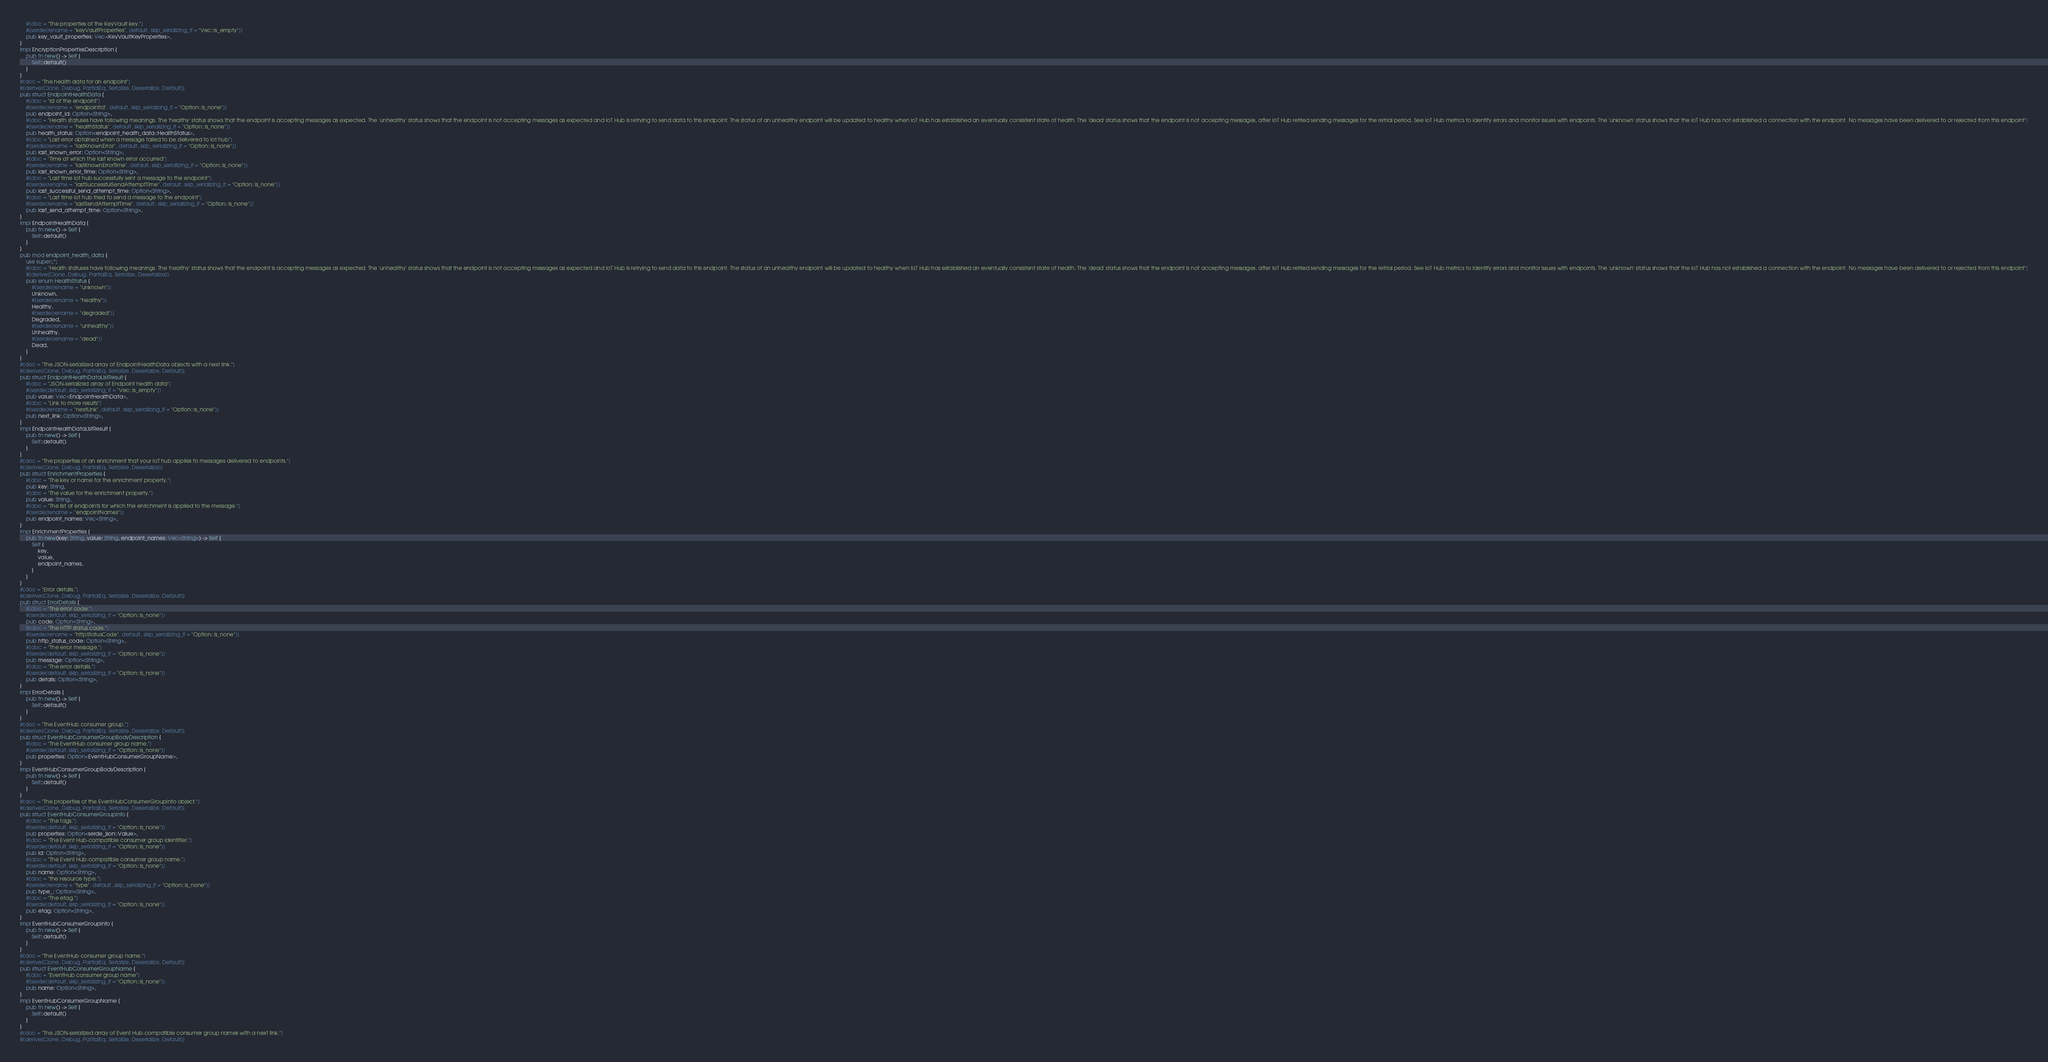<code> <loc_0><loc_0><loc_500><loc_500><_Rust_>    #[doc = "The properties of the KeyVault key."]
    #[serde(rename = "keyVaultProperties", default, skip_serializing_if = "Vec::is_empty")]
    pub key_vault_properties: Vec<KeyVaultKeyProperties>,
}
impl EncryptionPropertiesDescription {
    pub fn new() -> Self {
        Self::default()
    }
}
#[doc = "The health data for an endpoint"]
#[derive(Clone, Debug, PartialEq, Serialize, Deserialize, Default)]
pub struct EndpointHealthData {
    #[doc = "Id of the endpoint"]
    #[serde(rename = "endpointId", default, skip_serializing_if = "Option::is_none")]
    pub endpoint_id: Option<String>,
    #[doc = "Health statuses have following meanings. The 'healthy' status shows that the endpoint is accepting messages as expected. The 'unhealthy' status shows that the endpoint is not accepting messages as expected and IoT Hub is retrying to send data to this endpoint. The status of an unhealthy endpoint will be updated to healthy when IoT Hub has established an eventually consistent state of health. The 'dead' status shows that the endpoint is not accepting messages, after IoT Hub retried sending messages for the retrial period. See IoT Hub metrics to identify errors and monitor issues with endpoints. The 'unknown' status shows that the IoT Hub has not established a connection with the endpoint. No messages have been delivered to or rejected from this endpoint"]
    #[serde(rename = "healthStatus", default, skip_serializing_if = "Option::is_none")]
    pub health_status: Option<endpoint_health_data::HealthStatus>,
    #[doc = "Last error obtained when a message failed to be delivered to iot hub"]
    #[serde(rename = "lastKnownError", default, skip_serializing_if = "Option::is_none")]
    pub last_known_error: Option<String>,
    #[doc = "Time at which the last known error occurred"]
    #[serde(rename = "lastKnownErrorTime", default, skip_serializing_if = "Option::is_none")]
    pub last_known_error_time: Option<String>,
    #[doc = "Last time iot hub successfully sent a message to the endpoint"]
    #[serde(rename = "lastSuccessfulSendAttemptTime", default, skip_serializing_if = "Option::is_none")]
    pub last_successful_send_attempt_time: Option<String>,
    #[doc = "Last time iot hub tried to send a message to the endpoint"]
    #[serde(rename = "lastSendAttemptTime", default, skip_serializing_if = "Option::is_none")]
    pub last_send_attempt_time: Option<String>,
}
impl EndpointHealthData {
    pub fn new() -> Self {
        Self::default()
    }
}
pub mod endpoint_health_data {
    use super::*;
    #[doc = "Health statuses have following meanings. The 'healthy' status shows that the endpoint is accepting messages as expected. The 'unhealthy' status shows that the endpoint is not accepting messages as expected and IoT Hub is retrying to send data to this endpoint. The status of an unhealthy endpoint will be updated to healthy when IoT Hub has established an eventually consistent state of health. The 'dead' status shows that the endpoint is not accepting messages, after IoT Hub retried sending messages for the retrial period. See IoT Hub metrics to identify errors and monitor issues with endpoints. The 'unknown' status shows that the IoT Hub has not established a connection with the endpoint. No messages have been delivered to or rejected from this endpoint"]
    #[derive(Clone, Debug, PartialEq, Serialize, Deserialize)]
    pub enum HealthStatus {
        #[serde(rename = "unknown")]
        Unknown,
        #[serde(rename = "healthy")]
        Healthy,
        #[serde(rename = "degraded")]
        Degraded,
        #[serde(rename = "unhealthy")]
        Unhealthy,
        #[serde(rename = "dead")]
        Dead,
    }
}
#[doc = "The JSON-serialized array of EndpointHealthData objects with a next link."]
#[derive(Clone, Debug, PartialEq, Serialize, Deserialize, Default)]
pub struct EndpointHealthDataListResult {
    #[doc = "JSON-serialized array of Endpoint health data"]
    #[serde(default, skip_serializing_if = "Vec::is_empty")]
    pub value: Vec<EndpointHealthData>,
    #[doc = "Link to more results"]
    #[serde(rename = "nextLink", default, skip_serializing_if = "Option::is_none")]
    pub next_link: Option<String>,
}
impl EndpointHealthDataListResult {
    pub fn new() -> Self {
        Self::default()
    }
}
#[doc = "The properties of an enrichment that your IoT hub applies to messages delivered to endpoints."]
#[derive(Clone, Debug, PartialEq, Serialize, Deserialize)]
pub struct EnrichmentProperties {
    #[doc = "The key or name for the enrichment property."]
    pub key: String,
    #[doc = "The value for the enrichment property."]
    pub value: String,
    #[doc = "The list of endpoints for which the enrichment is applied to the message."]
    #[serde(rename = "endpointNames")]
    pub endpoint_names: Vec<String>,
}
impl EnrichmentProperties {
    pub fn new(key: String, value: String, endpoint_names: Vec<String>) -> Self {
        Self {
            key,
            value,
            endpoint_names,
        }
    }
}
#[doc = "Error details."]
#[derive(Clone, Debug, PartialEq, Serialize, Deserialize, Default)]
pub struct ErrorDetails {
    #[doc = "The error code."]
    #[serde(default, skip_serializing_if = "Option::is_none")]
    pub code: Option<String>,
    #[doc = "The HTTP status code."]
    #[serde(rename = "httpStatusCode", default, skip_serializing_if = "Option::is_none")]
    pub http_status_code: Option<String>,
    #[doc = "The error message."]
    #[serde(default, skip_serializing_if = "Option::is_none")]
    pub message: Option<String>,
    #[doc = "The error details."]
    #[serde(default, skip_serializing_if = "Option::is_none")]
    pub details: Option<String>,
}
impl ErrorDetails {
    pub fn new() -> Self {
        Self::default()
    }
}
#[doc = "The EventHub consumer group."]
#[derive(Clone, Debug, PartialEq, Serialize, Deserialize, Default)]
pub struct EventHubConsumerGroupBodyDescription {
    #[doc = "The EventHub consumer group name."]
    #[serde(default, skip_serializing_if = "Option::is_none")]
    pub properties: Option<EventHubConsumerGroupName>,
}
impl EventHubConsumerGroupBodyDescription {
    pub fn new() -> Self {
        Self::default()
    }
}
#[doc = "The properties of the EventHubConsumerGroupInfo object."]
#[derive(Clone, Debug, PartialEq, Serialize, Deserialize, Default)]
pub struct EventHubConsumerGroupInfo {
    #[doc = "The tags."]
    #[serde(default, skip_serializing_if = "Option::is_none")]
    pub properties: Option<serde_json::Value>,
    #[doc = "The Event Hub-compatible consumer group identifier."]
    #[serde(default, skip_serializing_if = "Option::is_none")]
    pub id: Option<String>,
    #[doc = "The Event Hub-compatible consumer group name."]
    #[serde(default, skip_serializing_if = "Option::is_none")]
    pub name: Option<String>,
    #[doc = "the resource type."]
    #[serde(rename = "type", default, skip_serializing_if = "Option::is_none")]
    pub type_: Option<String>,
    #[doc = "The etag."]
    #[serde(default, skip_serializing_if = "Option::is_none")]
    pub etag: Option<String>,
}
impl EventHubConsumerGroupInfo {
    pub fn new() -> Self {
        Self::default()
    }
}
#[doc = "The EventHub consumer group name."]
#[derive(Clone, Debug, PartialEq, Serialize, Deserialize, Default)]
pub struct EventHubConsumerGroupName {
    #[doc = "EventHub consumer group name"]
    #[serde(default, skip_serializing_if = "Option::is_none")]
    pub name: Option<String>,
}
impl EventHubConsumerGroupName {
    pub fn new() -> Self {
        Self::default()
    }
}
#[doc = "The JSON-serialized array of Event Hub-compatible consumer group names with a next link."]
#[derive(Clone, Debug, PartialEq, Serialize, Deserialize, Default)]</code> 